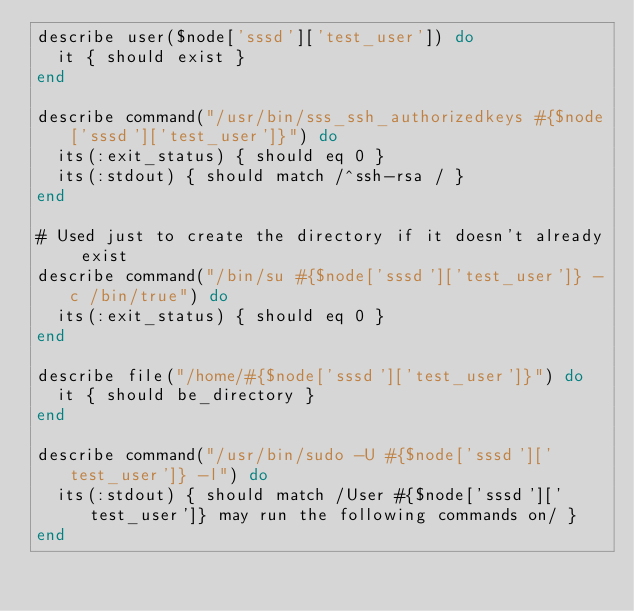<code> <loc_0><loc_0><loc_500><loc_500><_Ruby_>describe user($node['sssd']['test_user']) do
  it { should exist }
end

describe command("/usr/bin/sss_ssh_authorizedkeys #{$node['sssd']['test_user']}") do
  its(:exit_status) { should eq 0 }
  its(:stdout) { should match /^ssh-rsa / }
end

# Used just to create the directory if it doesn't already exist
describe command("/bin/su #{$node['sssd']['test_user']} -c /bin/true") do
  its(:exit_status) { should eq 0 }
end

describe file("/home/#{$node['sssd']['test_user']}") do
  it { should be_directory }
end

describe command("/usr/bin/sudo -U #{$node['sssd']['test_user']} -l") do
  its(:stdout) { should match /User #{$node['sssd']['test_user']} may run the following commands on/ }
end
</code> 